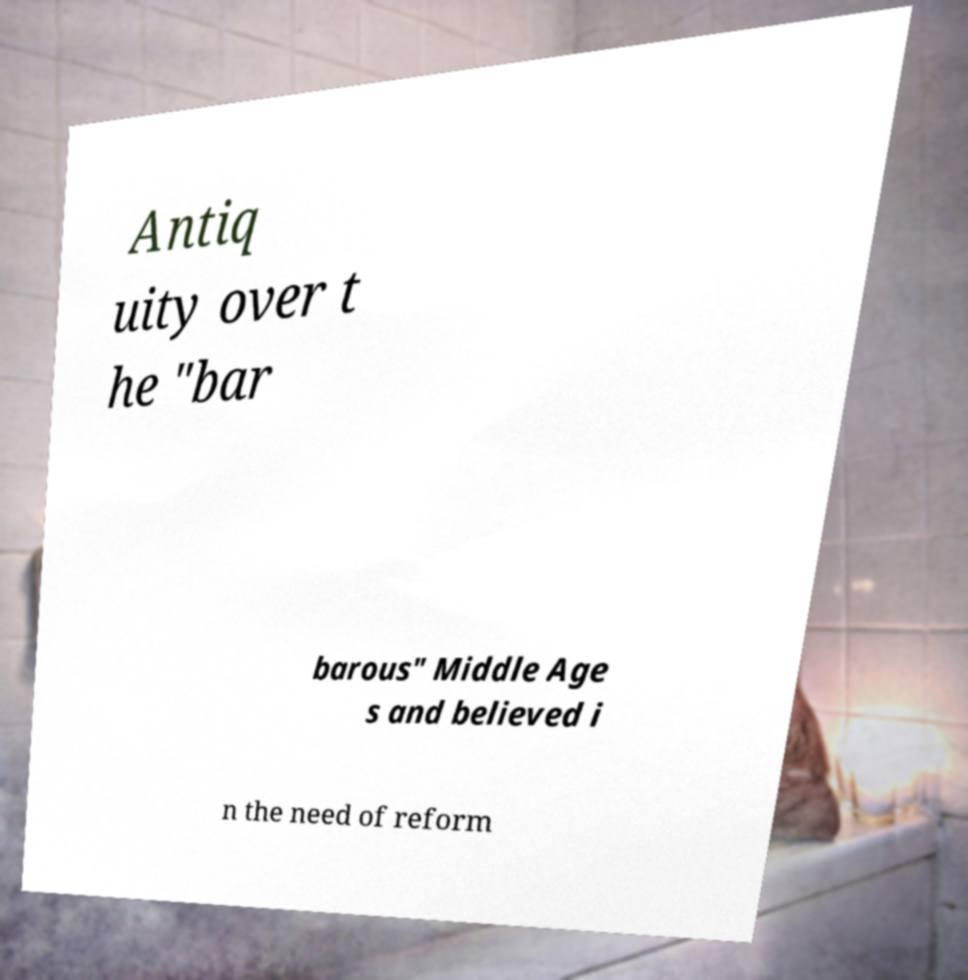Could you extract and type out the text from this image? Antiq uity over t he "bar barous" Middle Age s and believed i n the need of reform 